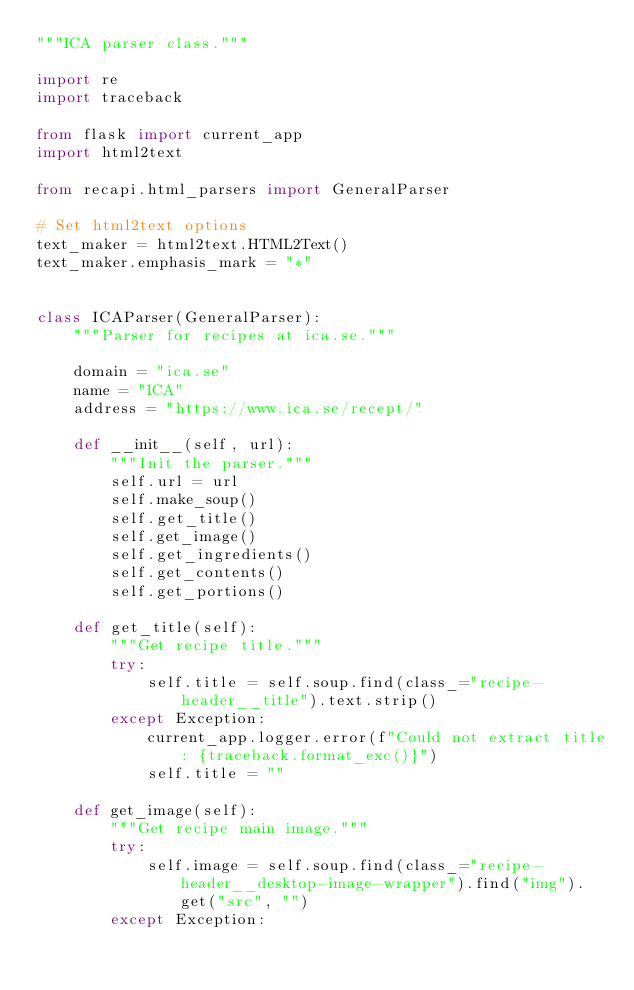Convert code to text. <code><loc_0><loc_0><loc_500><loc_500><_Python_>"""ICA parser class."""

import re
import traceback

from flask import current_app
import html2text

from recapi.html_parsers import GeneralParser

# Set html2text options
text_maker = html2text.HTML2Text()
text_maker.emphasis_mark = "*"


class ICAParser(GeneralParser):
    """Parser for recipes at ica.se."""

    domain = "ica.se"
    name = "ICA"
    address = "https://www.ica.se/recept/"

    def __init__(self, url):
        """Init the parser."""
        self.url = url
        self.make_soup()
        self.get_title()
        self.get_image()
        self.get_ingredients()
        self.get_contents()
        self.get_portions()

    def get_title(self):
        """Get recipe title."""
        try:
            self.title = self.soup.find(class_="recipe-header__title").text.strip()
        except Exception:
            current_app.logger.error(f"Could not extract title: {traceback.format_exc()}")
            self.title = ""

    def get_image(self):
        """Get recipe main image."""
        try:
            self.image = self.soup.find(class_="recipe-header__desktop-image-wrapper").find("img").get("src", "")
        except Exception:</code> 